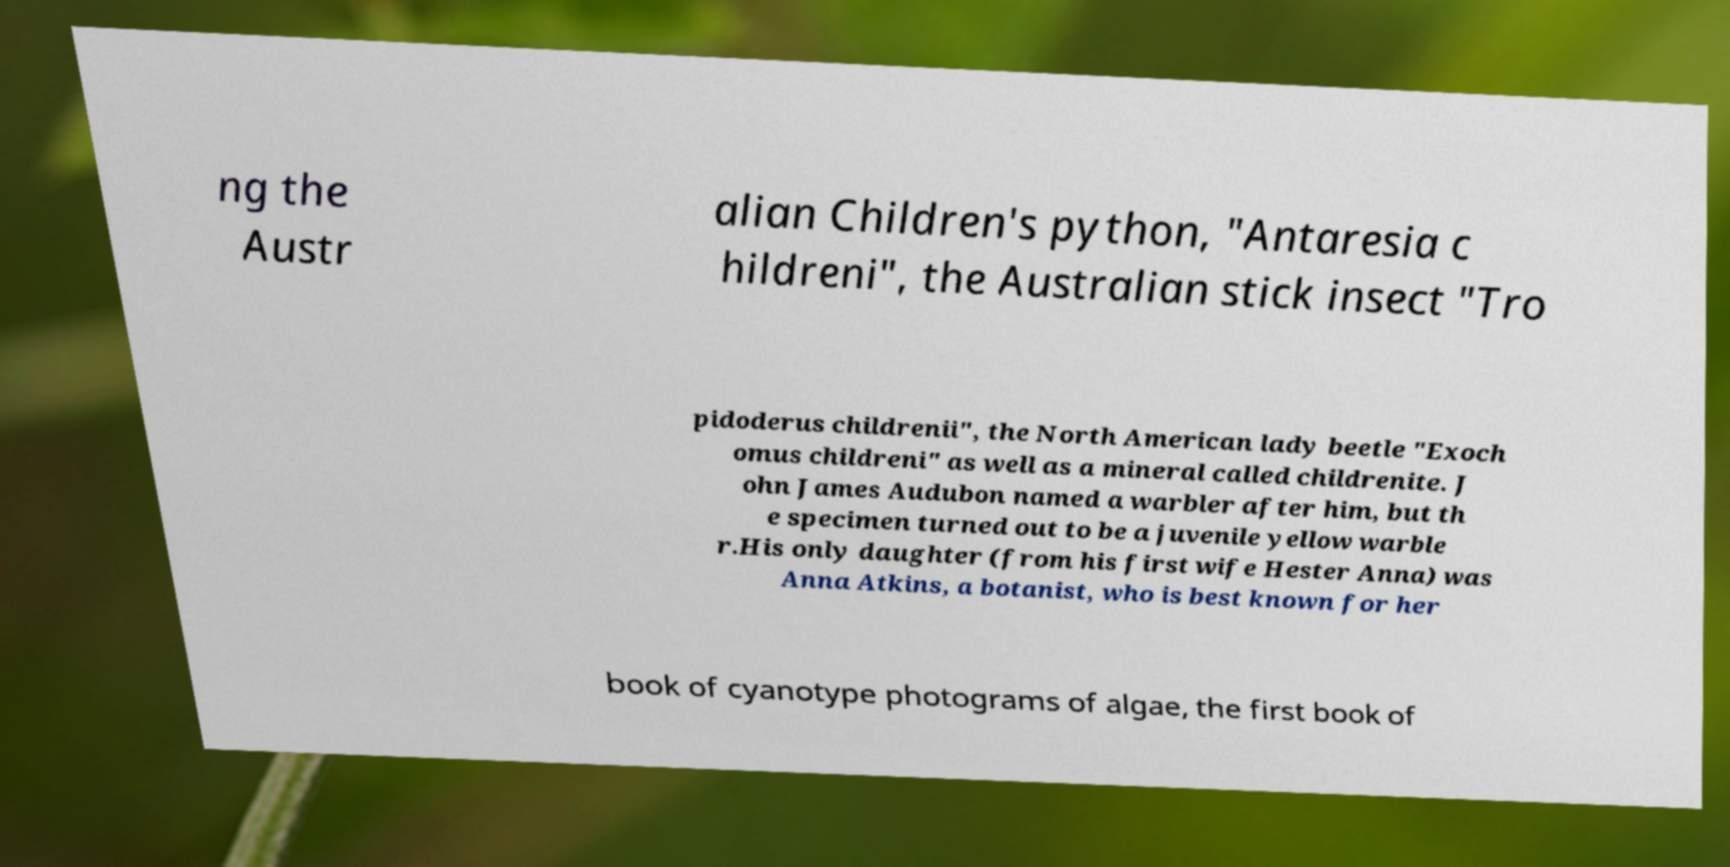There's text embedded in this image that I need extracted. Can you transcribe it verbatim? ng the Austr alian Children's python, "Antaresia c hildreni", the Australian stick insect "Tro pidoderus childrenii", the North American lady beetle "Exoch omus childreni" as well as a mineral called childrenite. J ohn James Audubon named a warbler after him, but th e specimen turned out to be a juvenile yellow warble r.His only daughter (from his first wife Hester Anna) was Anna Atkins, a botanist, who is best known for her book of cyanotype photograms of algae, the first book of 